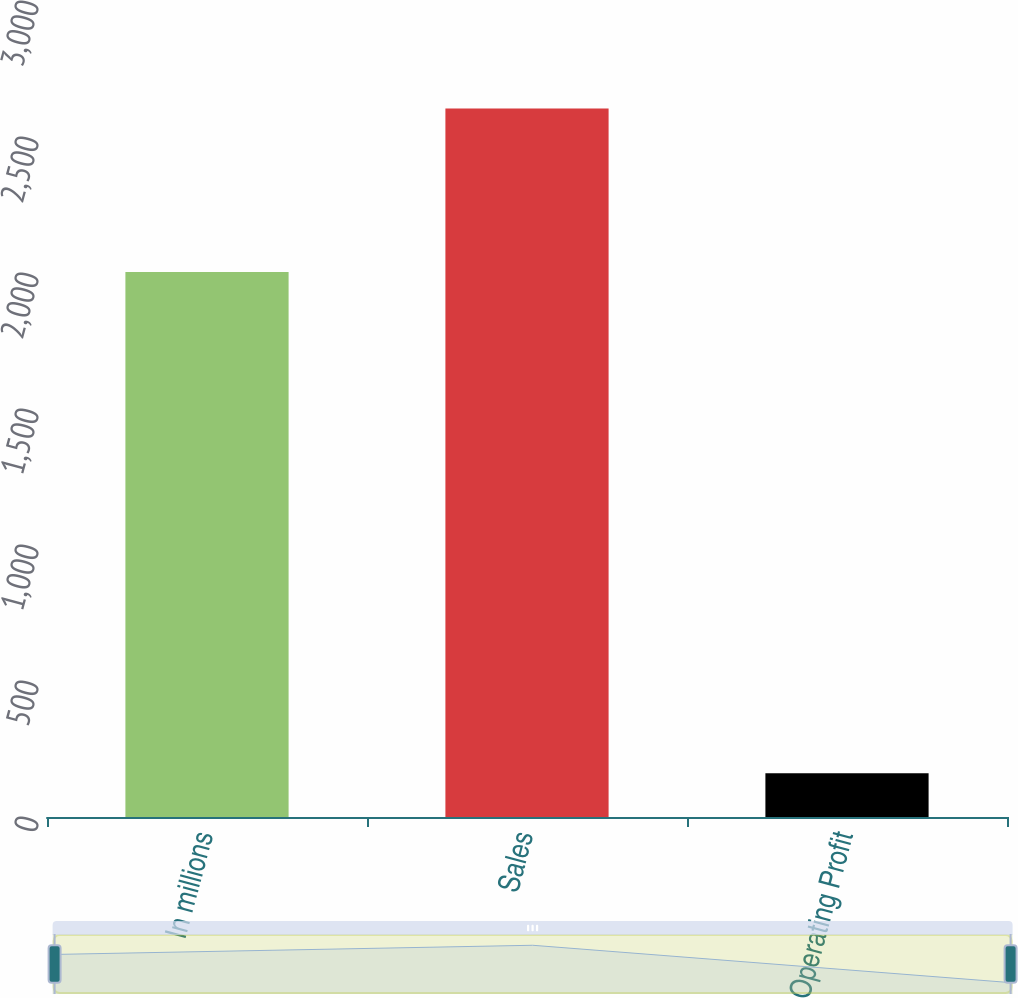Convert chart. <chart><loc_0><loc_0><loc_500><loc_500><bar_chart><fcel>In millions<fcel>Sales<fcel>Operating Profit<nl><fcel>2004<fcel>2605<fcel>161<nl></chart> 